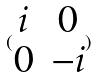<formula> <loc_0><loc_0><loc_500><loc_500>( \begin{matrix} i & 0 \\ 0 & - i \end{matrix} )</formula> 